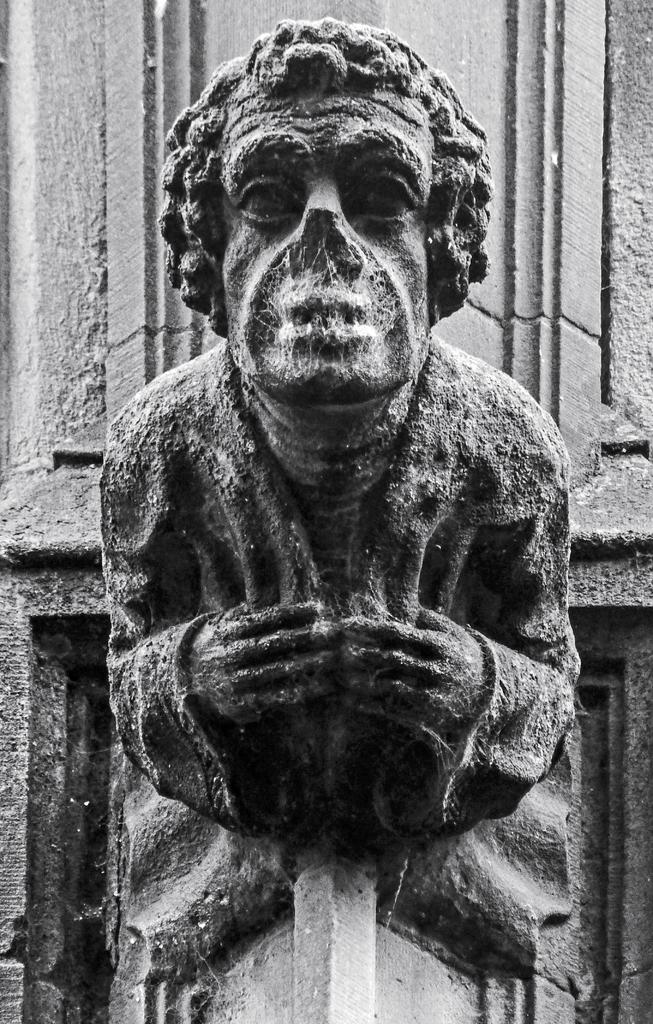What is the main subject in the middle of the image? There is a statue in the middle of the image. What is the color scheme of the image? The image is a black and white photography. How many girls are present in the image? There are no girls present in the image; it features a statue. What type of pest can be seen crawling on the statue in the image? There is no pest visible on the statue in the image. 